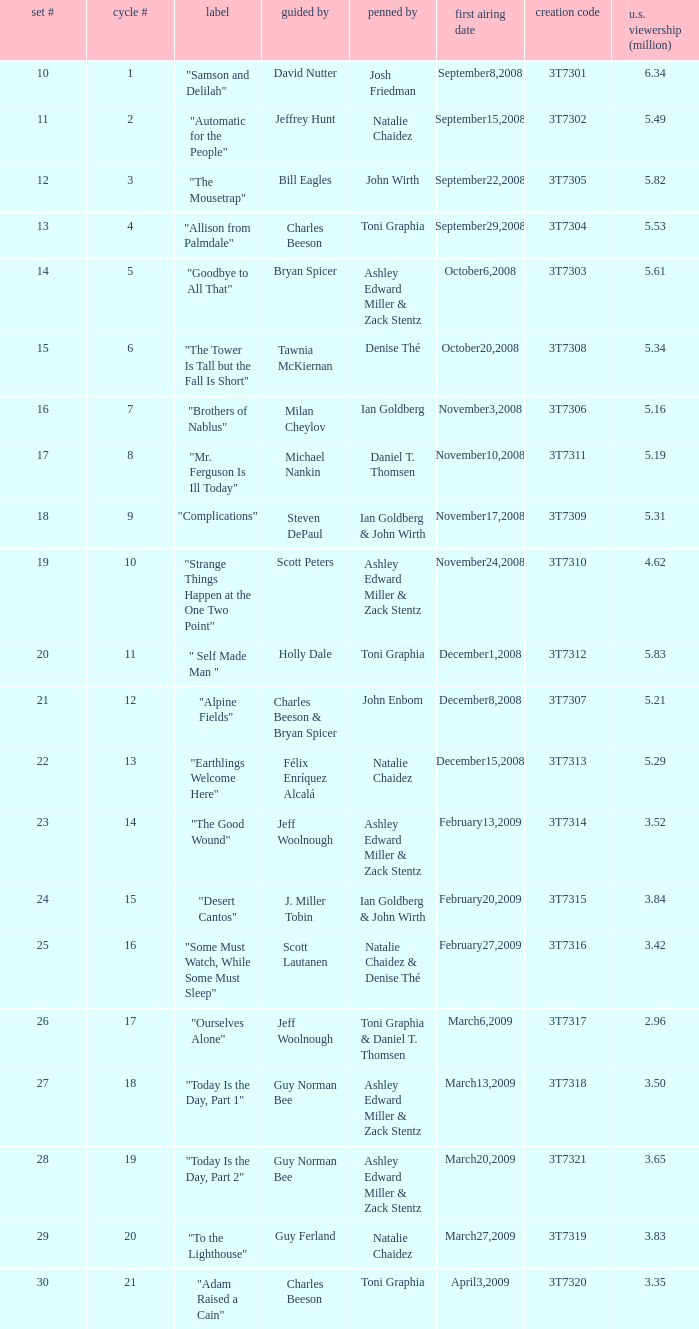Parse the full table. {'header': ['set #', 'cycle #', 'label', 'guided by', 'penned by', 'first airing date', 'creation code', 'u.s. viewership (million)'], 'rows': [['10', '1', '"Samson and Delilah"', 'David Nutter', 'Josh Friedman', 'September8,2008', '3T7301', '6.34'], ['11', '2', '"Automatic for the People"', 'Jeffrey Hunt', 'Natalie Chaidez', 'September15,2008', '3T7302', '5.49'], ['12', '3', '"The Mousetrap"', 'Bill Eagles', 'John Wirth', 'September22,2008', '3T7305', '5.82'], ['13', '4', '"Allison from Palmdale"', 'Charles Beeson', 'Toni Graphia', 'September29,2008', '3T7304', '5.53'], ['14', '5', '"Goodbye to All That"', 'Bryan Spicer', 'Ashley Edward Miller & Zack Stentz', 'October6,2008', '3T7303', '5.61'], ['15', '6', '"The Tower Is Tall but the Fall Is Short"', 'Tawnia McKiernan', 'Denise Thé', 'October20,2008', '3T7308', '5.34'], ['16', '7', '"Brothers of Nablus"', 'Milan Cheylov', 'Ian Goldberg', 'November3,2008', '3T7306', '5.16'], ['17', '8', '"Mr. Ferguson Is Ill Today"', 'Michael Nankin', 'Daniel T. Thomsen', 'November10,2008', '3T7311', '5.19'], ['18', '9', '"Complications"', 'Steven DePaul', 'Ian Goldberg & John Wirth', 'November17,2008', '3T7309', '5.31'], ['19', '10', '"Strange Things Happen at the One Two Point"', 'Scott Peters', 'Ashley Edward Miller & Zack Stentz', 'November24,2008', '3T7310', '4.62'], ['20', '11', '" Self Made Man "', 'Holly Dale', 'Toni Graphia', 'December1,2008', '3T7312', '5.83'], ['21', '12', '"Alpine Fields"', 'Charles Beeson & Bryan Spicer', 'John Enbom', 'December8,2008', '3T7307', '5.21'], ['22', '13', '"Earthlings Welcome Here"', 'Félix Enríquez Alcalá', 'Natalie Chaidez', 'December15,2008', '3T7313', '5.29'], ['23', '14', '"The Good Wound"', 'Jeff Woolnough', 'Ashley Edward Miller & Zack Stentz', 'February13,2009', '3T7314', '3.52'], ['24', '15', '"Desert Cantos"', 'J. Miller Tobin', 'Ian Goldberg & John Wirth', 'February20,2009', '3T7315', '3.84'], ['25', '16', '"Some Must Watch, While Some Must Sleep"', 'Scott Lautanen', 'Natalie Chaidez & Denise Thé', 'February27,2009', '3T7316', '3.42'], ['26', '17', '"Ourselves Alone"', 'Jeff Woolnough', 'Toni Graphia & Daniel T. Thomsen', 'March6,2009', '3T7317', '2.96'], ['27', '18', '"Today Is the Day, Part 1"', 'Guy Norman Bee', 'Ashley Edward Miller & Zack Stentz', 'March13,2009', '3T7318', '3.50'], ['28', '19', '"Today Is the Day, Part 2"', 'Guy Norman Bee', 'Ashley Edward Miller & Zack Stentz', 'March20,2009', '3T7321', '3.65'], ['29', '20', '"To the Lighthouse"', 'Guy Ferland', 'Natalie Chaidez', 'March27,2009', '3T7319', '3.83'], ['30', '21', '"Adam Raised a Cain"', 'Charles Beeson', 'Toni Graphia', 'April3,2009', '3T7320', '3.35']]} Which episode number drew in 3.84 million viewers in the U.S.? 24.0. 